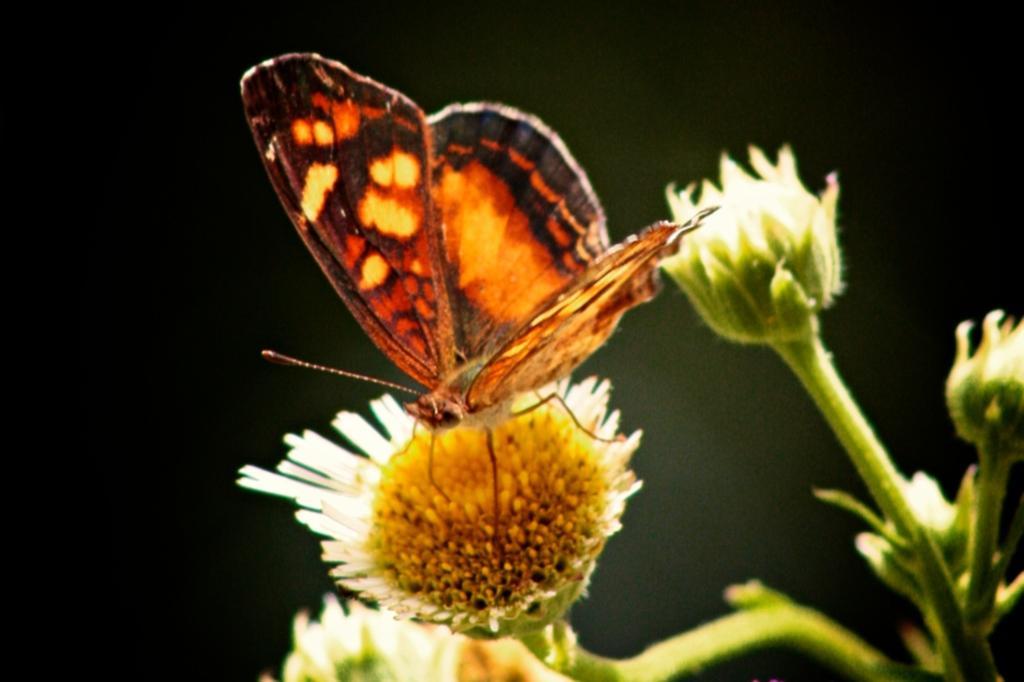Please provide a concise description of this image. In this picture we can see butterfly. This is standing on the bud. On the right we can see flowers and plant. 